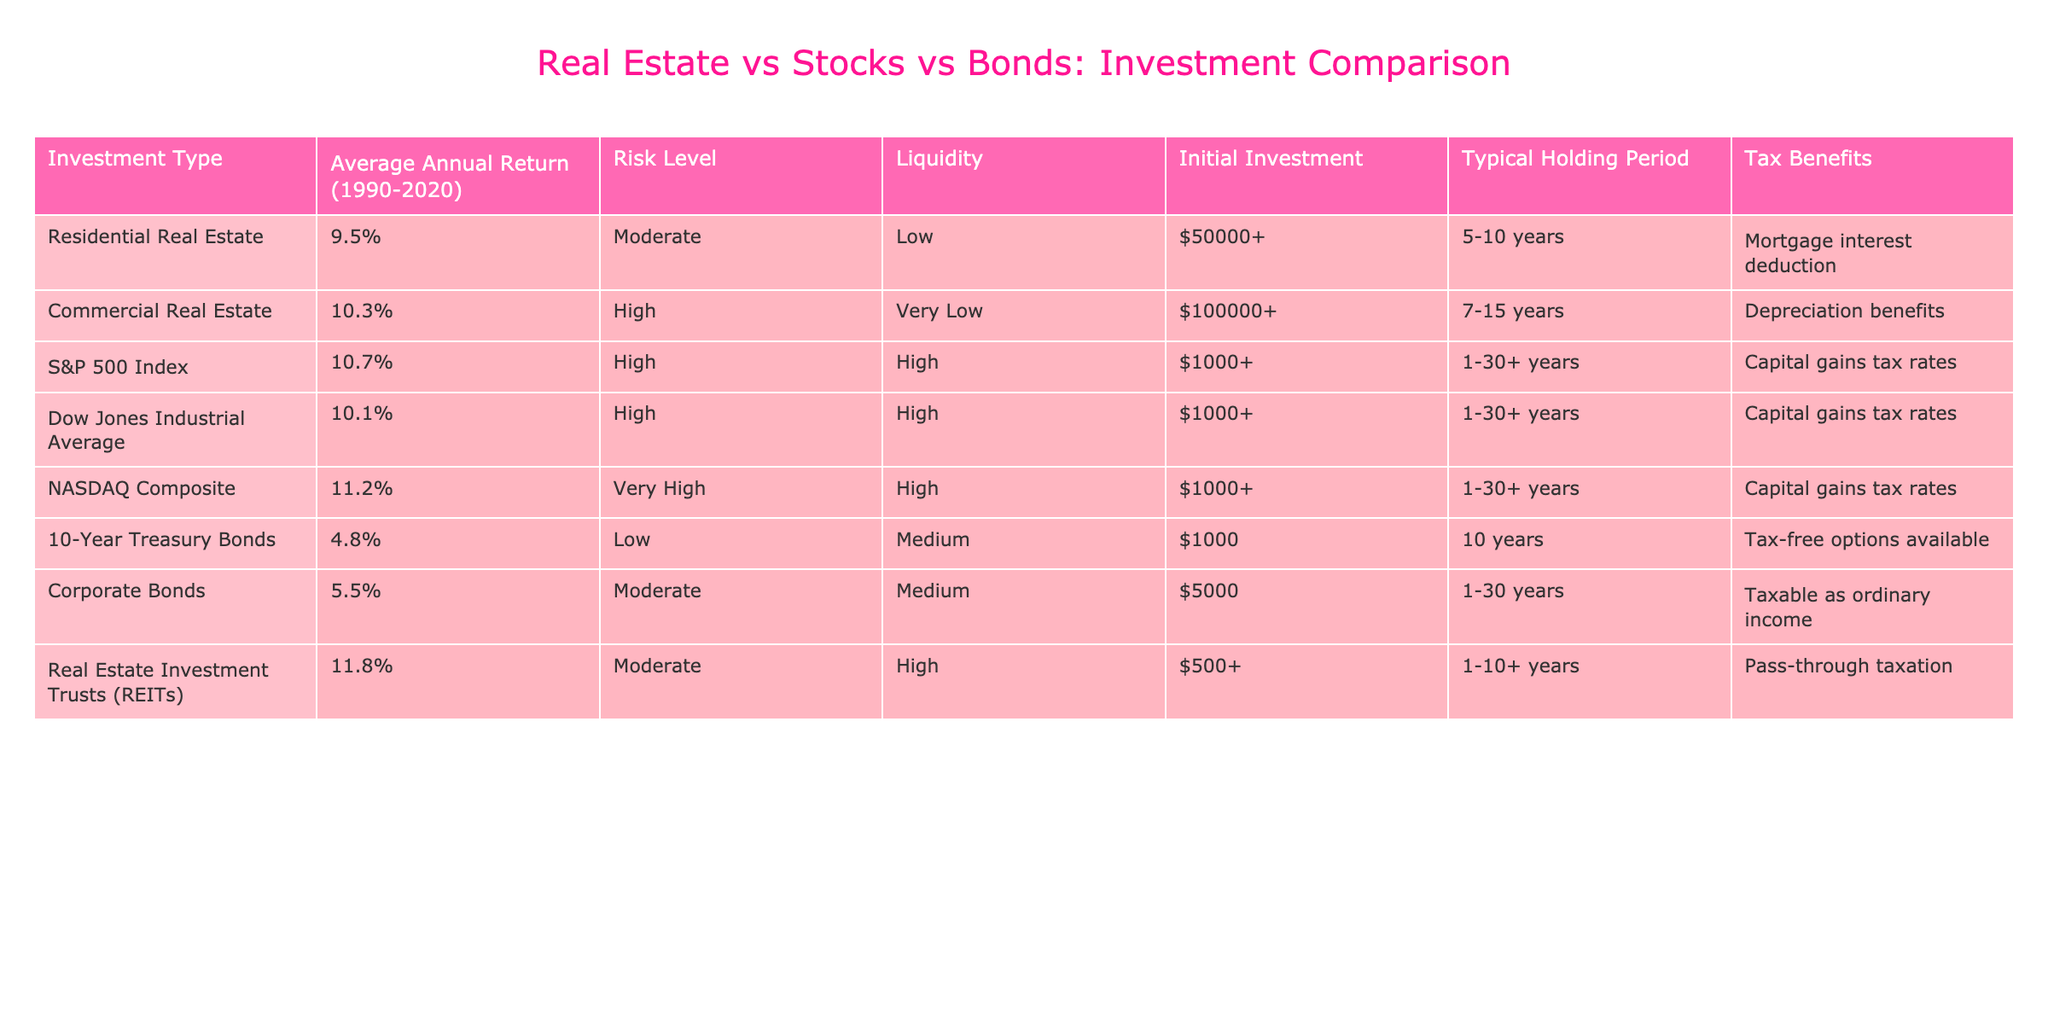What is the average annual return for Residential Real Estate? The table specifies that the average annual return for Residential Real Estate is listed as 9.5%.
Answer: 9.5% Which investment type has the highest average annual return? By comparing the average annual returns in the table, the investment type with the highest return is Real Estate Investment Trusts (REITs), which is 11.8%.
Answer: Real Estate Investment Trusts (REITs) What is the risk level of Corporate Bonds? According to the table, Corporate Bonds have a risk level classified as Moderate.
Answer: Moderate How does the average annual return of 10-Year Treasury Bonds compare to the average annual return of NASDAQ Composite? The average annual return of 10-Year Treasury Bonds is 4.8% while NASDAQ Composite is at 11.2%. The difference is 11.2% - 4.8% = 6.4%. Therefore, NASDAQ Composite’s return is higher by 6.4%.
Answer: NASDAQ Composite is higher by 6.4% What is the typical holding period for Commercial Real Estate? The table indicates that the typical holding period for Commercial Real Estate is between 7 to 15 years.
Answer: 7-15 years Are Real Estate Investment Trusts (REITs) considered to have a high liquidity level? The liquidity level for Real Estate Investment Trusts (REITs) is classified as High in the table. Thus, the statement is true.
Answer: Yes What is the average annual return of the S&P 500 Index in comparison to Residential Real Estate? The average return for the S&P 500 Index is 10.7%, which is higher than Residential Real Estate’s 9.5%. The difference is 10.7% - 9.5% = 1.2%.
Answer: 1.2% higher If someone invests $50,000 in Residential Real Estate, would they meet the initial investment requirement for Commercial Real Estate? The initial investment required for Commercial Real Estate is $100,000+, which is greater than $50,000. Therefore, they would not meet the requirement.
Answer: No Which investment has a lower average annual return: 10-Year Treasury Bonds or Corporate Bonds? The average annual return for 10-Year Treasury Bonds is 4.8%, while Corporate Bonds have 5.5%. Since 4.8% is less than 5.5%, 10-Year Treasury Bonds have a lower return.
Answer: 10-Year Treasury Bonds If an investor is primarily concerned with tax benefits, which investment type should they consider? The table highlights that Residential Real Estate offers mortgage interest deduction, Commercial Real Estate provides depreciation benefits, and REITs have pass-through taxation, making all beneficial for tax incentives. Hence, they can consider any of these options.
Answer: Any of these (Residential Real Estate, Commercial Real Estate, REITs) 